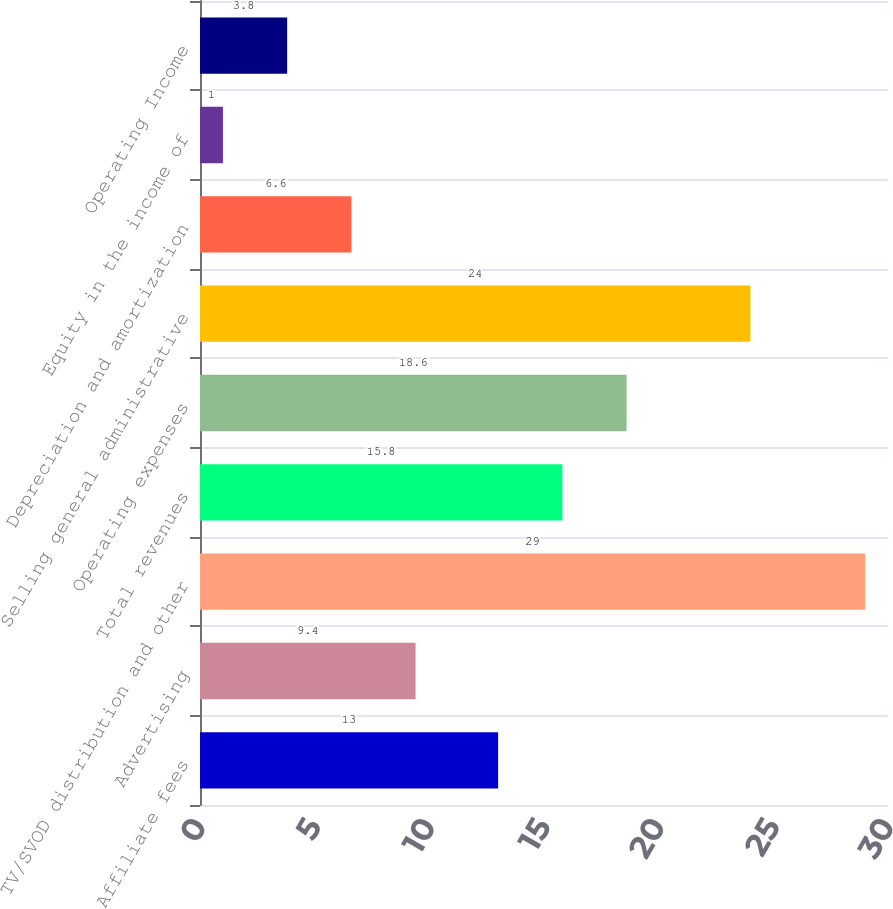<chart> <loc_0><loc_0><loc_500><loc_500><bar_chart><fcel>Affiliate fees<fcel>Advertising<fcel>TV/SVOD distribution and other<fcel>Total revenues<fcel>Operating expenses<fcel>Selling general administrative<fcel>Depreciation and amortization<fcel>Equity in the income of<fcel>Operating Income<nl><fcel>13<fcel>9.4<fcel>29<fcel>15.8<fcel>18.6<fcel>24<fcel>6.6<fcel>1<fcel>3.8<nl></chart> 